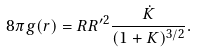Convert formula to latex. <formula><loc_0><loc_0><loc_500><loc_500>8 \pi g ( r ) = R R ^ { \prime 2 } \frac { \dot { K } } { ( 1 + K ) ^ { 3 / 2 } } .</formula> 